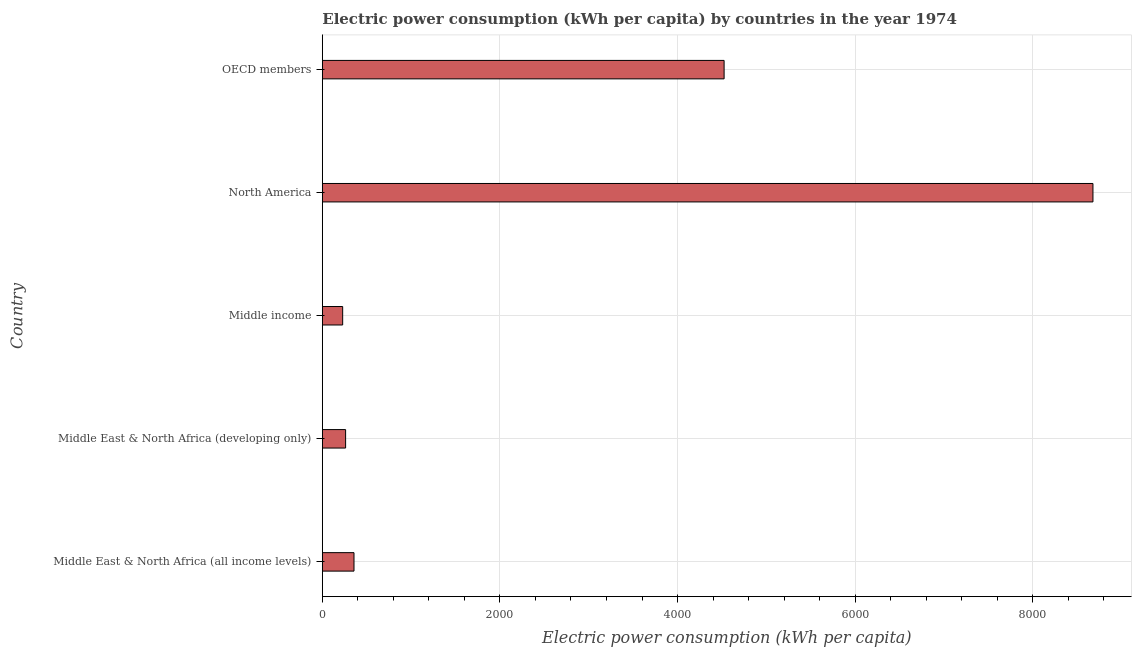What is the title of the graph?
Offer a terse response. Electric power consumption (kWh per capita) by countries in the year 1974. What is the label or title of the X-axis?
Provide a succinct answer. Electric power consumption (kWh per capita). What is the electric power consumption in North America?
Your answer should be very brief. 8678.1. Across all countries, what is the maximum electric power consumption?
Keep it short and to the point. 8678.1. Across all countries, what is the minimum electric power consumption?
Provide a succinct answer. 229.03. In which country was the electric power consumption maximum?
Your response must be concise. North America. In which country was the electric power consumption minimum?
Your answer should be compact. Middle income. What is the sum of the electric power consumption?
Offer a very short reply. 1.41e+04. What is the difference between the electric power consumption in Middle East & North Africa (all income levels) and OECD members?
Offer a very short reply. -4167.85. What is the average electric power consumption per country?
Provide a short and direct response. 2810.05. What is the median electric power consumption?
Give a very brief answer. 356.59. What is the ratio of the electric power consumption in Middle East & North Africa (developing only) to that in Middle income?
Provide a succinct answer. 1.14. What is the difference between the highest and the second highest electric power consumption?
Make the answer very short. 4153.66. Is the sum of the electric power consumption in Middle East & North Africa (all income levels) and North America greater than the maximum electric power consumption across all countries?
Provide a succinct answer. Yes. What is the difference between the highest and the lowest electric power consumption?
Ensure brevity in your answer.  8449.07. What is the difference between two consecutive major ticks on the X-axis?
Offer a terse response. 2000. What is the Electric power consumption (kWh per capita) of Middle East & North Africa (all income levels)?
Make the answer very short. 356.59. What is the Electric power consumption (kWh per capita) of Middle East & North Africa (developing only)?
Your answer should be very brief. 262.09. What is the Electric power consumption (kWh per capita) in Middle income?
Ensure brevity in your answer.  229.03. What is the Electric power consumption (kWh per capita) in North America?
Offer a very short reply. 8678.1. What is the Electric power consumption (kWh per capita) in OECD members?
Offer a terse response. 4524.44. What is the difference between the Electric power consumption (kWh per capita) in Middle East & North Africa (all income levels) and Middle East & North Africa (developing only)?
Give a very brief answer. 94.5. What is the difference between the Electric power consumption (kWh per capita) in Middle East & North Africa (all income levels) and Middle income?
Provide a short and direct response. 127.56. What is the difference between the Electric power consumption (kWh per capita) in Middle East & North Africa (all income levels) and North America?
Your answer should be very brief. -8321.51. What is the difference between the Electric power consumption (kWh per capita) in Middle East & North Africa (all income levels) and OECD members?
Keep it short and to the point. -4167.85. What is the difference between the Electric power consumption (kWh per capita) in Middle East & North Africa (developing only) and Middle income?
Offer a terse response. 33.06. What is the difference between the Electric power consumption (kWh per capita) in Middle East & North Africa (developing only) and North America?
Keep it short and to the point. -8416.01. What is the difference between the Electric power consumption (kWh per capita) in Middle East & North Africa (developing only) and OECD members?
Make the answer very short. -4262.35. What is the difference between the Electric power consumption (kWh per capita) in Middle income and North America?
Provide a short and direct response. -8449.07. What is the difference between the Electric power consumption (kWh per capita) in Middle income and OECD members?
Ensure brevity in your answer.  -4295.41. What is the difference between the Electric power consumption (kWh per capita) in North America and OECD members?
Make the answer very short. 4153.66. What is the ratio of the Electric power consumption (kWh per capita) in Middle East & North Africa (all income levels) to that in Middle East & North Africa (developing only)?
Provide a short and direct response. 1.36. What is the ratio of the Electric power consumption (kWh per capita) in Middle East & North Africa (all income levels) to that in Middle income?
Give a very brief answer. 1.56. What is the ratio of the Electric power consumption (kWh per capita) in Middle East & North Africa (all income levels) to that in North America?
Your answer should be compact. 0.04. What is the ratio of the Electric power consumption (kWh per capita) in Middle East & North Africa (all income levels) to that in OECD members?
Provide a short and direct response. 0.08. What is the ratio of the Electric power consumption (kWh per capita) in Middle East & North Africa (developing only) to that in Middle income?
Your answer should be compact. 1.14. What is the ratio of the Electric power consumption (kWh per capita) in Middle East & North Africa (developing only) to that in North America?
Provide a short and direct response. 0.03. What is the ratio of the Electric power consumption (kWh per capita) in Middle East & North Africa (developing only) to that in OECD members?
Provide a short and direct response. 0.06. What is the ratio of the Electric power consumption (kWh per capita) in Middle income to that in North America?
Provide a succinct answer. 0.03. What is the ratio of the Electric power consumption (kWh per capita) in Middle income to that in OECD members?
Provide a succinct answer. 0.05. What is the ratio of the Electric power consumption (kWh per capita) in North America to that in OECD members?
Provide a short and direct response. 1.92. 